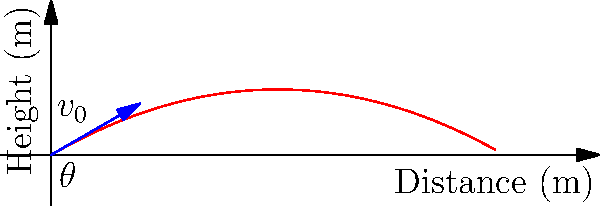A humanitarian aid package is launched from a relief aircraft to reach a disaster-stricken area. The package is released with an initial velocity of 50 m/s at an angle of 30° above the horizontal. Assuming no air resistance, calculate the maximum horizontal distance the package will travel before reaching the ground. How might this information be used to minimize potential harm in aid delivery? To solve this problem, we'll use the equations of projectile motion and trigonometry:

1) The range (R) of a projectile is given by the formula:
   $$R = \frac{v_0^2 \sin(2\theta)}{g}$$
   where $v_0$ is the initial velocity, $\theta$ is the launch angle, and $g$ is the acceleration due to gravity (9.8 m/s²).

2) We have:
   $v_0 = 50$ m/s
   $\theta = 30°$
   $g = 9.8$ m/s²

3) First, calculate $\sin(2\theta)$:
   $\sin(2\theta) = \sin(60°) = \frac{\sqrt{3}}{2}$

4) Now, substitute these values into the range equation:
   $$R = \frac{(50)^2 \cdot \frac{\sqrt{3}}{2}}{9.8}$$

5) Simplify:
   $$R = \frac{2500 \cdot \sqrt{3}}{19.6} \approx 220.8$$

6) Therefore, the package will travel approximately 220.8 meters horizontally before hitting the ground.

This information can be used to ensure aid packages are dropped from a safe distance to reach their intended targets without endangering people on the ground. It also helps in planning drop zones and assessing potential risks in humanitarian operations.
Answer: 220.8 meters 